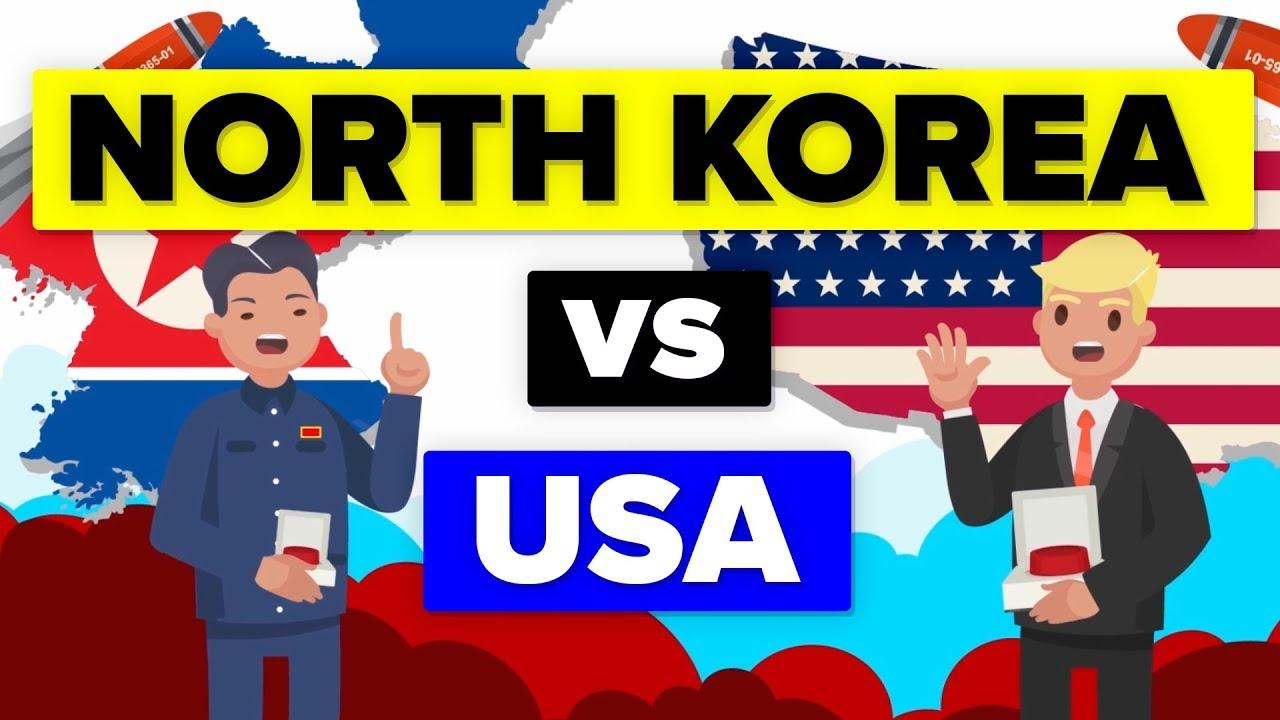Identify some key points in this picture. The color of the star in the USA flag is white, not blue. The star on the North Korean flag is red. I, [Name], firmly believe that the color of the tie is red, not white as some may claim. 